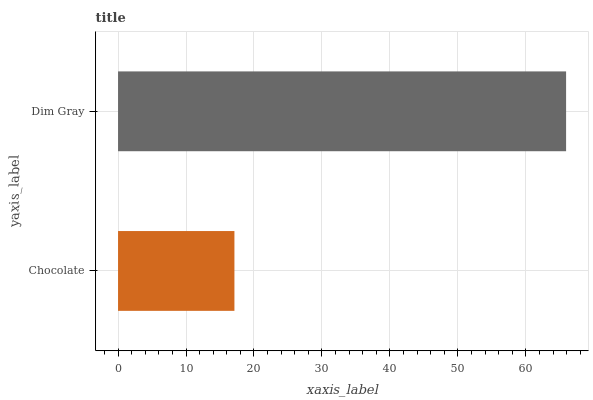Is Chocolate the minimum?
Answer yes or no. Yes. Is Dim Gray the maximum?
Answer yes or no. Yes. Is Dim Gray the minimum?
Answer yes or no. No. Is Dim Gray greater than Chocolate?
Answer yes or no. Yes. Is Chocolate less than Dim Gray?
Answer yes or no. Yes. Is Chocolate greater than Dim Gray?
Answer yes or no. No. Is Dim Gray less than Chocolate?
Answer yes or no. No. Is Dim Gray the high median?
Answer yes or no. Yes. Is Chocolate the low median?
Answer yes or no. Yes. Is Chocolate the high median?
Answer yes or no. No. Is Dim Gray the low median?
Answer yes or no. No. 